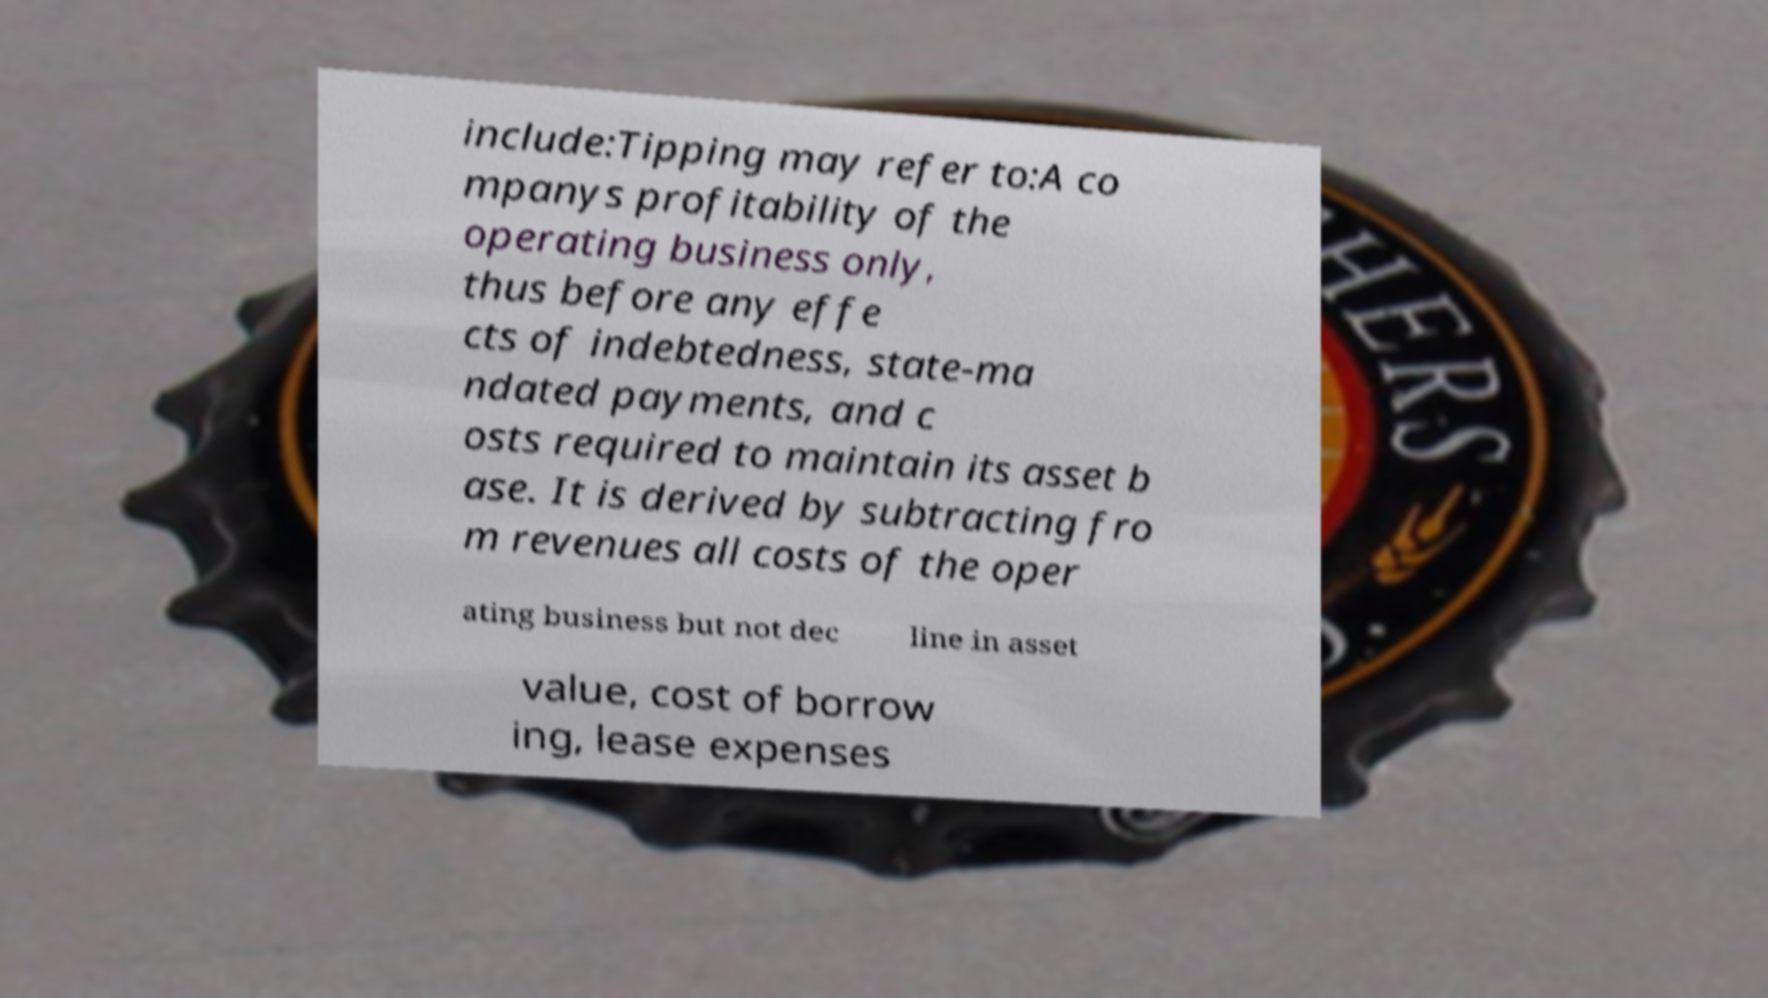There's text embedded in this image that I need extracted. Can you transcribe it verbatim? include:Tipping may refer to:A co mpanys profitability of the operating business only, thus before any effe cts of indebtedness, state-ma ndated payments, and c osts required to maintain its asset b ase. It is derived by subtracting fro m revenues all costs of the oper ating business but not dec line in asset value, cost of borrow ing, lease expenses 